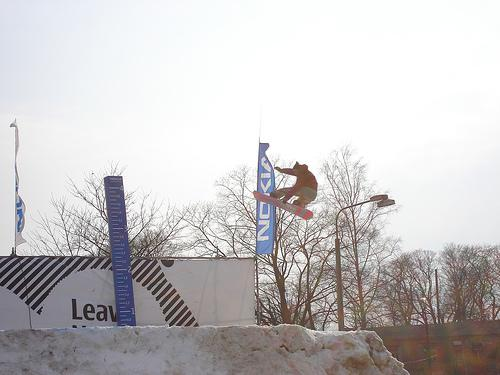Question: what sign is the man jumping by?
Choices:
A. Nokia.
B. Motorola.
C. At and t.
D. Verizon.
Answer with the letter. Answer: A Question: why is a ruler by the signs?
Choices:
A. To measure height of people.
B. To measure jumps.
C. To measure car height.
D. To measure tree height.
Answer with the letter. Answer: B Question: what color is the man's snowboard?
Choices:
A. White and pink.
B. Green.
C. Blue.
D. Red.
Answer with the letter. Answer: A Question: who is portrayed riding the snowboard?
Choices:
A. A man.
B. A woman.
C. A child.
D. A dog.
Answer with the letter. Answer: A Question: how high does the ruler measure?
Choices:
A. 3 meters.
B. Four meters.
C. 2 meters.
D. 5 meters.
Answer with the letter. Answer: B Question: where is the large billboard?
Choices:
A. Next to the tree.
B. Next to the ski lift.
C. Next to the ski lodge.
D. Behind the snow jump.
Answer with the letter. Answer: D 